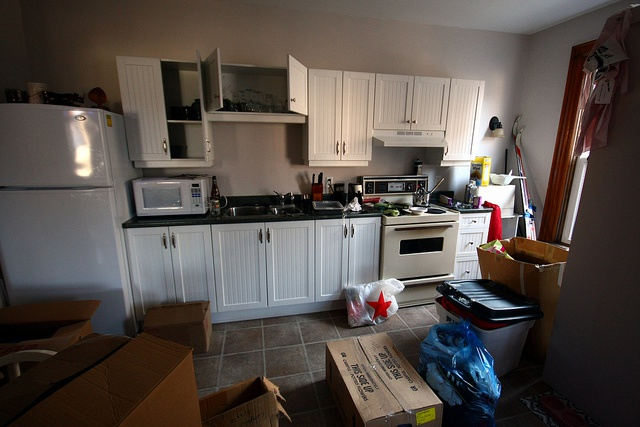Describe the objects in this image and their specific colors. I can see refrigerator in black, gray, and darkgray tones, oven in black, darkgray, and gray tones, microwave in black and gray tones, skis in black, gray, white, and darkgray tones, and sink in black, gray, and darkgray tones in this image. 